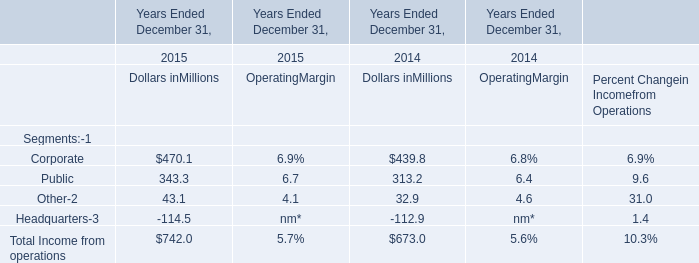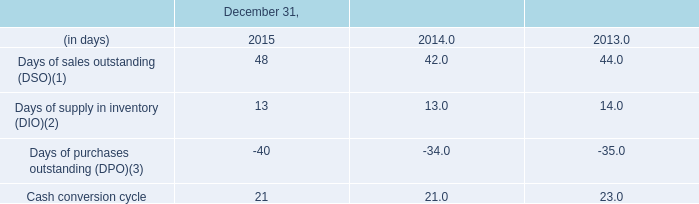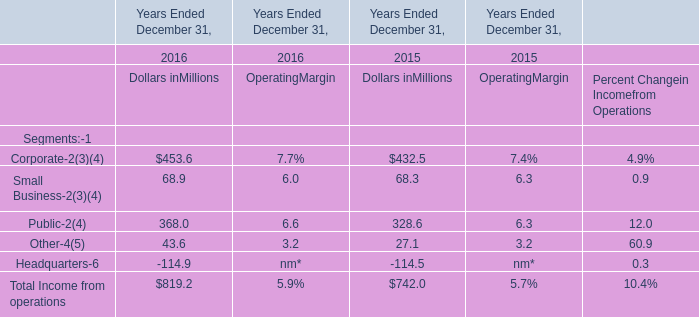How many kinds of Segments are greater than 300 in 2015 for Dollars in Millions? 
Answer: 2. 